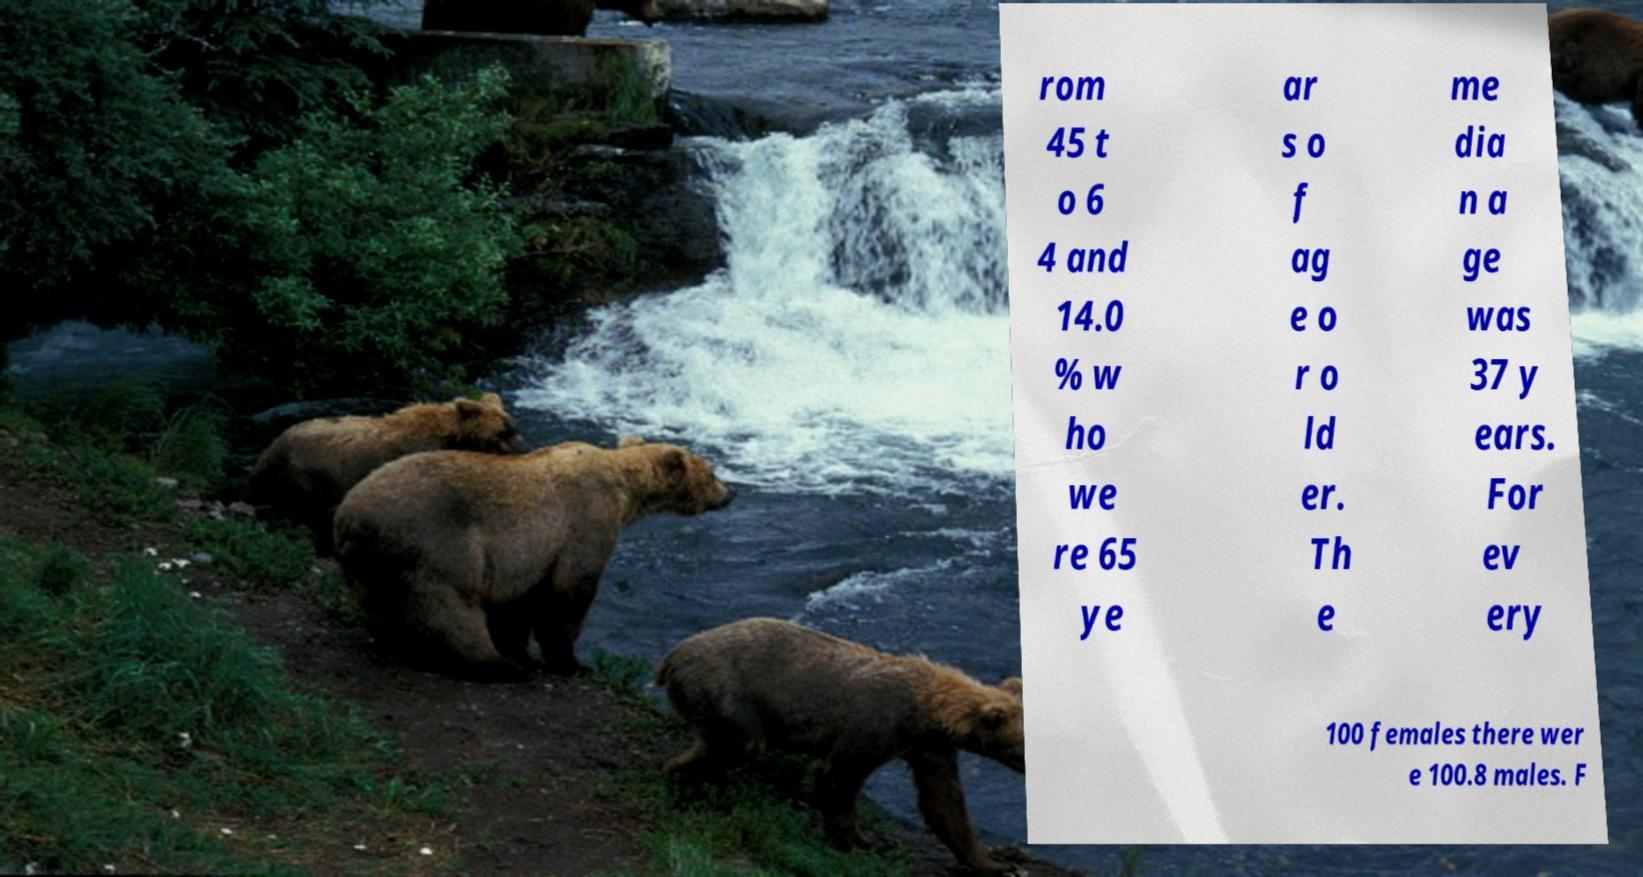Could you assist in decoding the text presented in this image and type it out clearly? rom 45 t o 6 4 and 14.0 % w ho we re 65 ye ar s o f ag e o r o ld er. Th e me dia n a ge was 37 y ears. For ev ery 100 females there wer e 100.8 males. F 